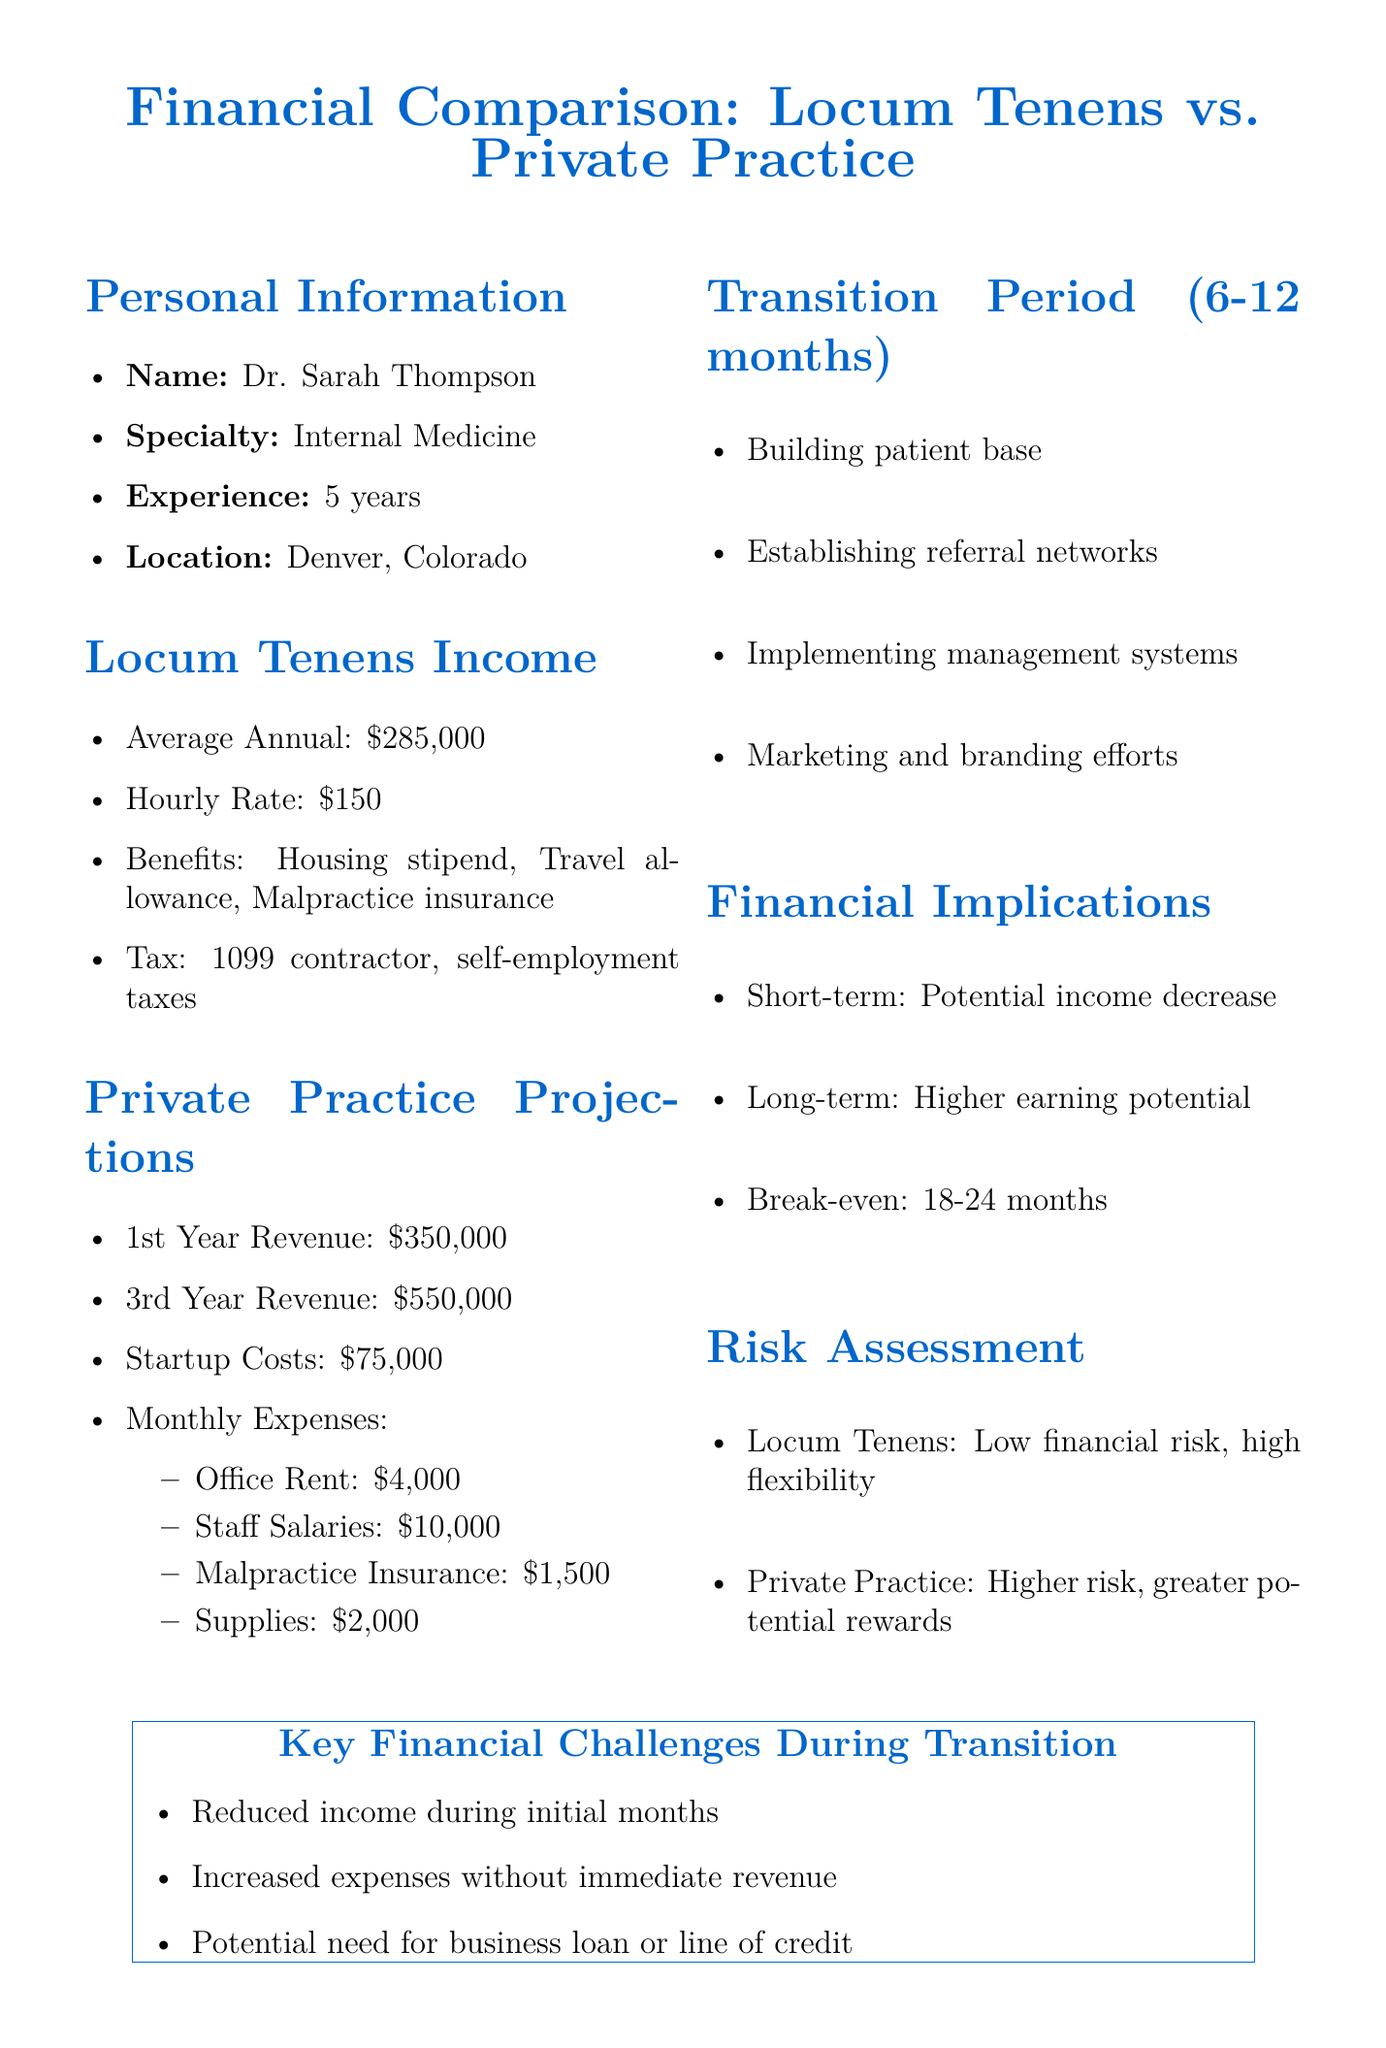What is the average annual income from locum tenens work? The document states that the average annual income from locum tenens work is $285,000.
Answer: $285,000 What are the projected revenues for the third year of private practice? The projected revenue for the third year of private practice is explicitly mentioned as $550,000.
Answer: $550,000 What are the startup costs for starting a private practice? The startup costs for starting a private practice are noted as $75,000 in the document.
Answer: $75,000 What is the duration of the transition period? The transition period is specified to last from 6 to 12 months.
Answer: 6-12 months What are the key financial challenges during the transition? Among the challenges mentioned, one specific challenge is "reduced income during initial months."
Answer: Reduced income during initial months What are the potential long-term financial implications of transitioning to private practice? The document states that the long-term implication is "higher earning potential and equity building in own practice."
Answer: Higher earning potential and equity building in own practice How does the financial risk of locum tenens compare to private practice? The document assesses locum tenens as having "low financial risk" compared to private practice's "higher financial risk."
Answer: Low financial risk What are the monthly office rent expenses for private practice? The monthly office rent for the private practice is stated to be $4,000.
Answer: $4,000 What is the projected break-even timeframe after starting the practice? According to the document, the projected break-even is 18 to 24 months after practice start.
Answer: 18-24 months 